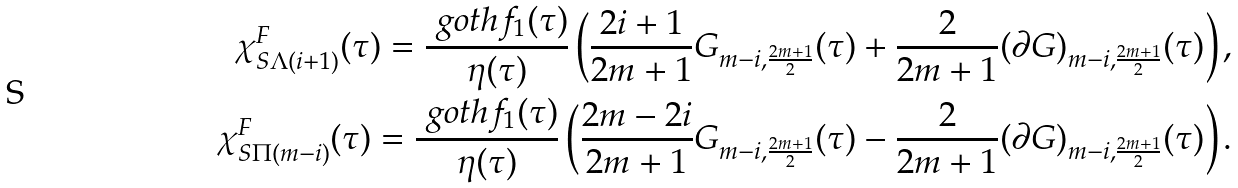<formula> <loc_0><loc_0><loc_500><loc_500>\chi ^ { F } _ { S \Lambda ( i + 1 ) } ( \tau ) = \frac { \ g o t h { f } _ { 1 } ( \tau ) } { \eta ( \tau ) } \left ( \frac { 2 i + 1 } { 2 m + 1 } G _ { m - i , \frac { 2 m + 1 } { 2 } } ( \tau ) + \frac { 2 } { 2 m + 1 } ( \partial G ) _ { m - i , \frac { 2 m + 1 } { 2 } } ( \tau ) \right ) , \\ \chi ^ { F } _ { S \Pi ( m - i ) } ( \tau ) = \frac { \ g o t h { f } _ { 1 } ( \tau ) } { \eta ( \tau ) } \left ( \frac { 2 m - 2 i } { 2 m + 1 } G _ { m - i , \frac { 2 m + 1 } { 2 } } ( \tau ) - \frac { 2 } { 2 m + 1 } ( \partial G ) _ { m - i , \frac { 2 m + 1 } { 2 } } ( \tau ) \right ) .</formula> 